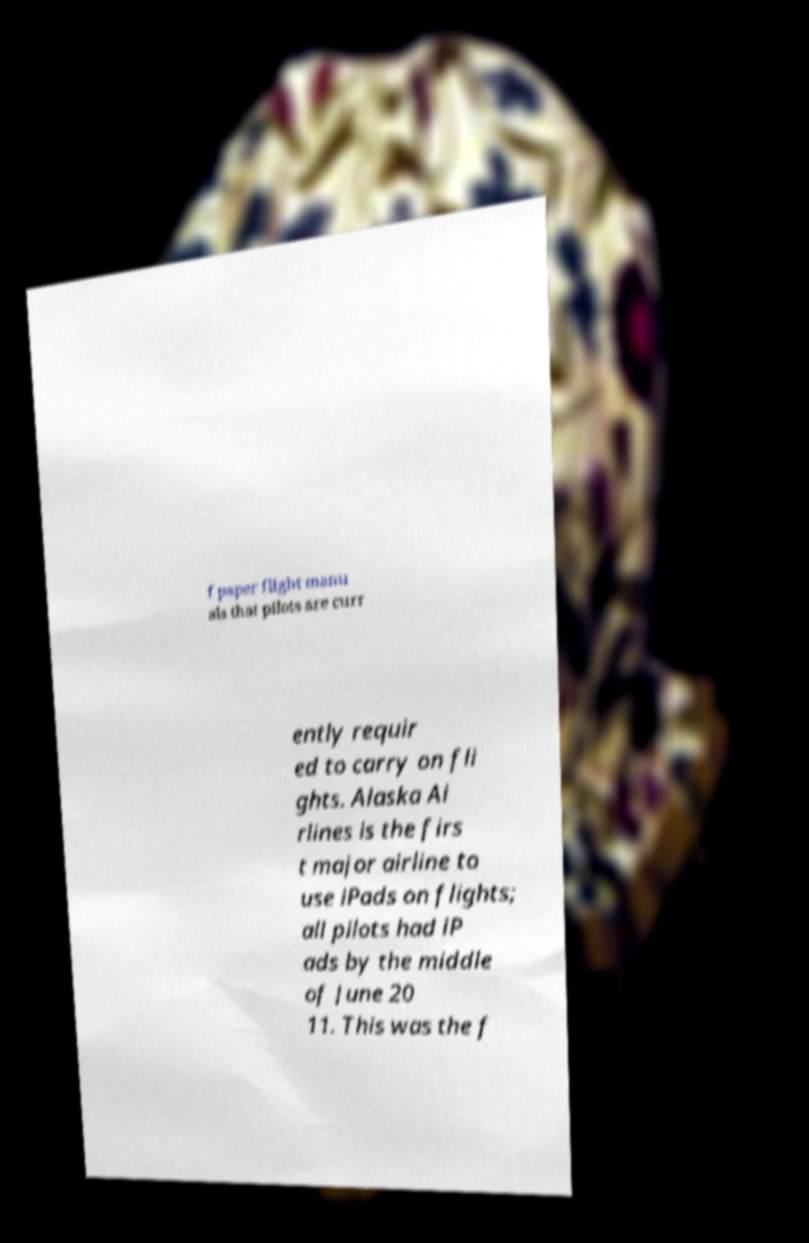Can you accurately transcribe the text from the provided image for me? f paper flight manu als that pilots are curr ently requir ed to carry on fli ghts. Alaska Ai rlines is the firs t major airline to use iPads on flights; all pilots had iP ads by the middle of June 20 11. This was the f 